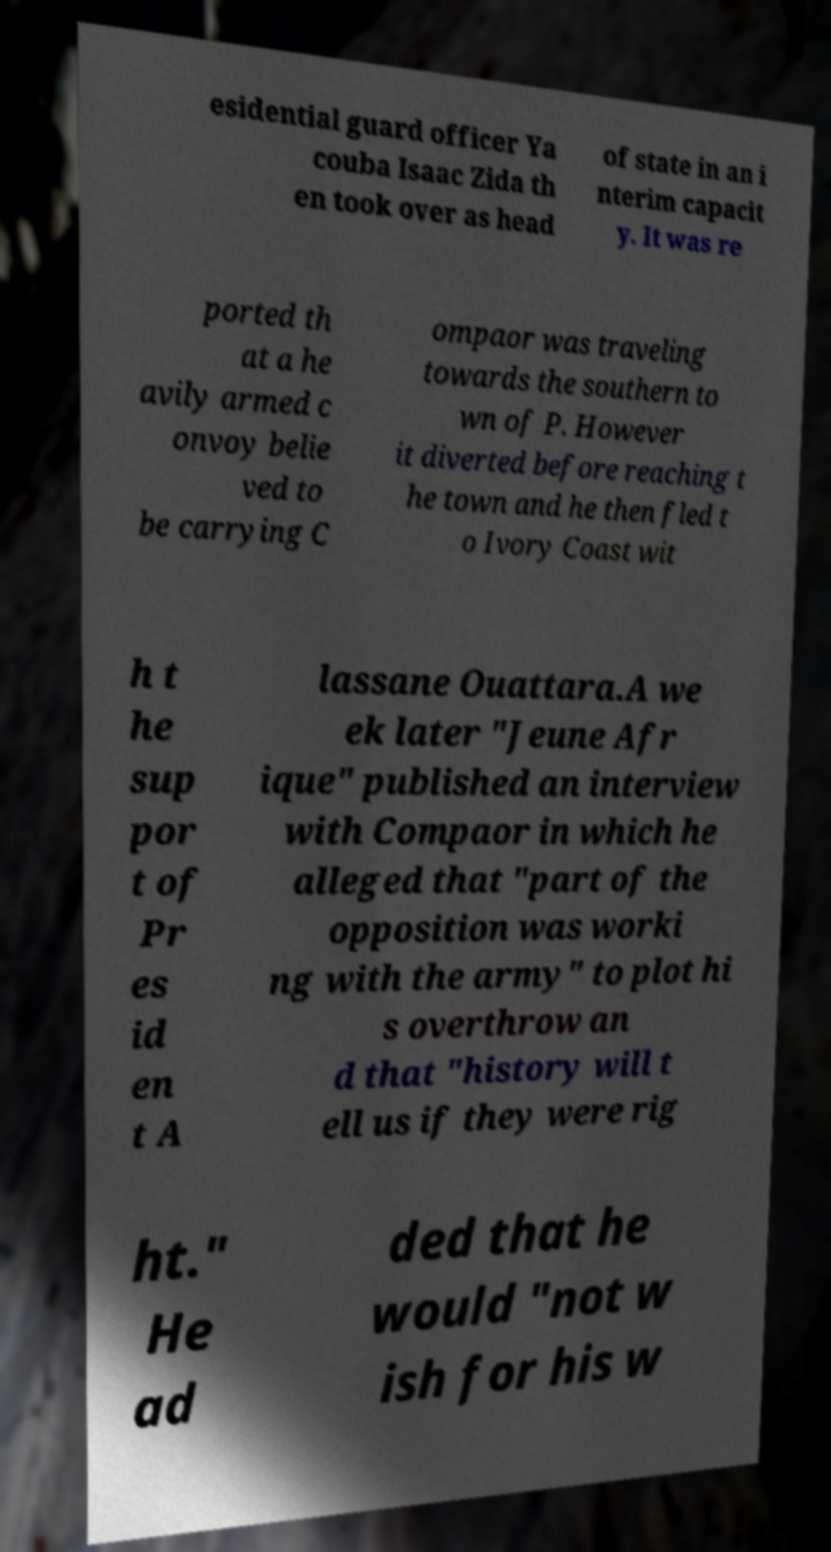Can you read and provide the text displayed in the image?This photo seems to have some interesting text. Can you extract and type it out for me? esidential guard officer Ya couba Isaac Zida th en took over as head of state in an i nterim capacit y. It was re ported th at a he avily armed c onvoy belie ved to be carrying C ompaor was traveling towards the southern to wn of P. However it diverted before reaching t he town and he then fled t o Ivory Coast wit h t he sup por t of Pr es id en t A lassane Ouattara.A we ek later "Jeune Afr ique" published an interview with Compaor in which he alleged that "part of the opposition was worki ng with the army" to plot hi s overthrow an d that "history will t ell us if they were rig ht." He ad ded that he would "not w ish for his w 